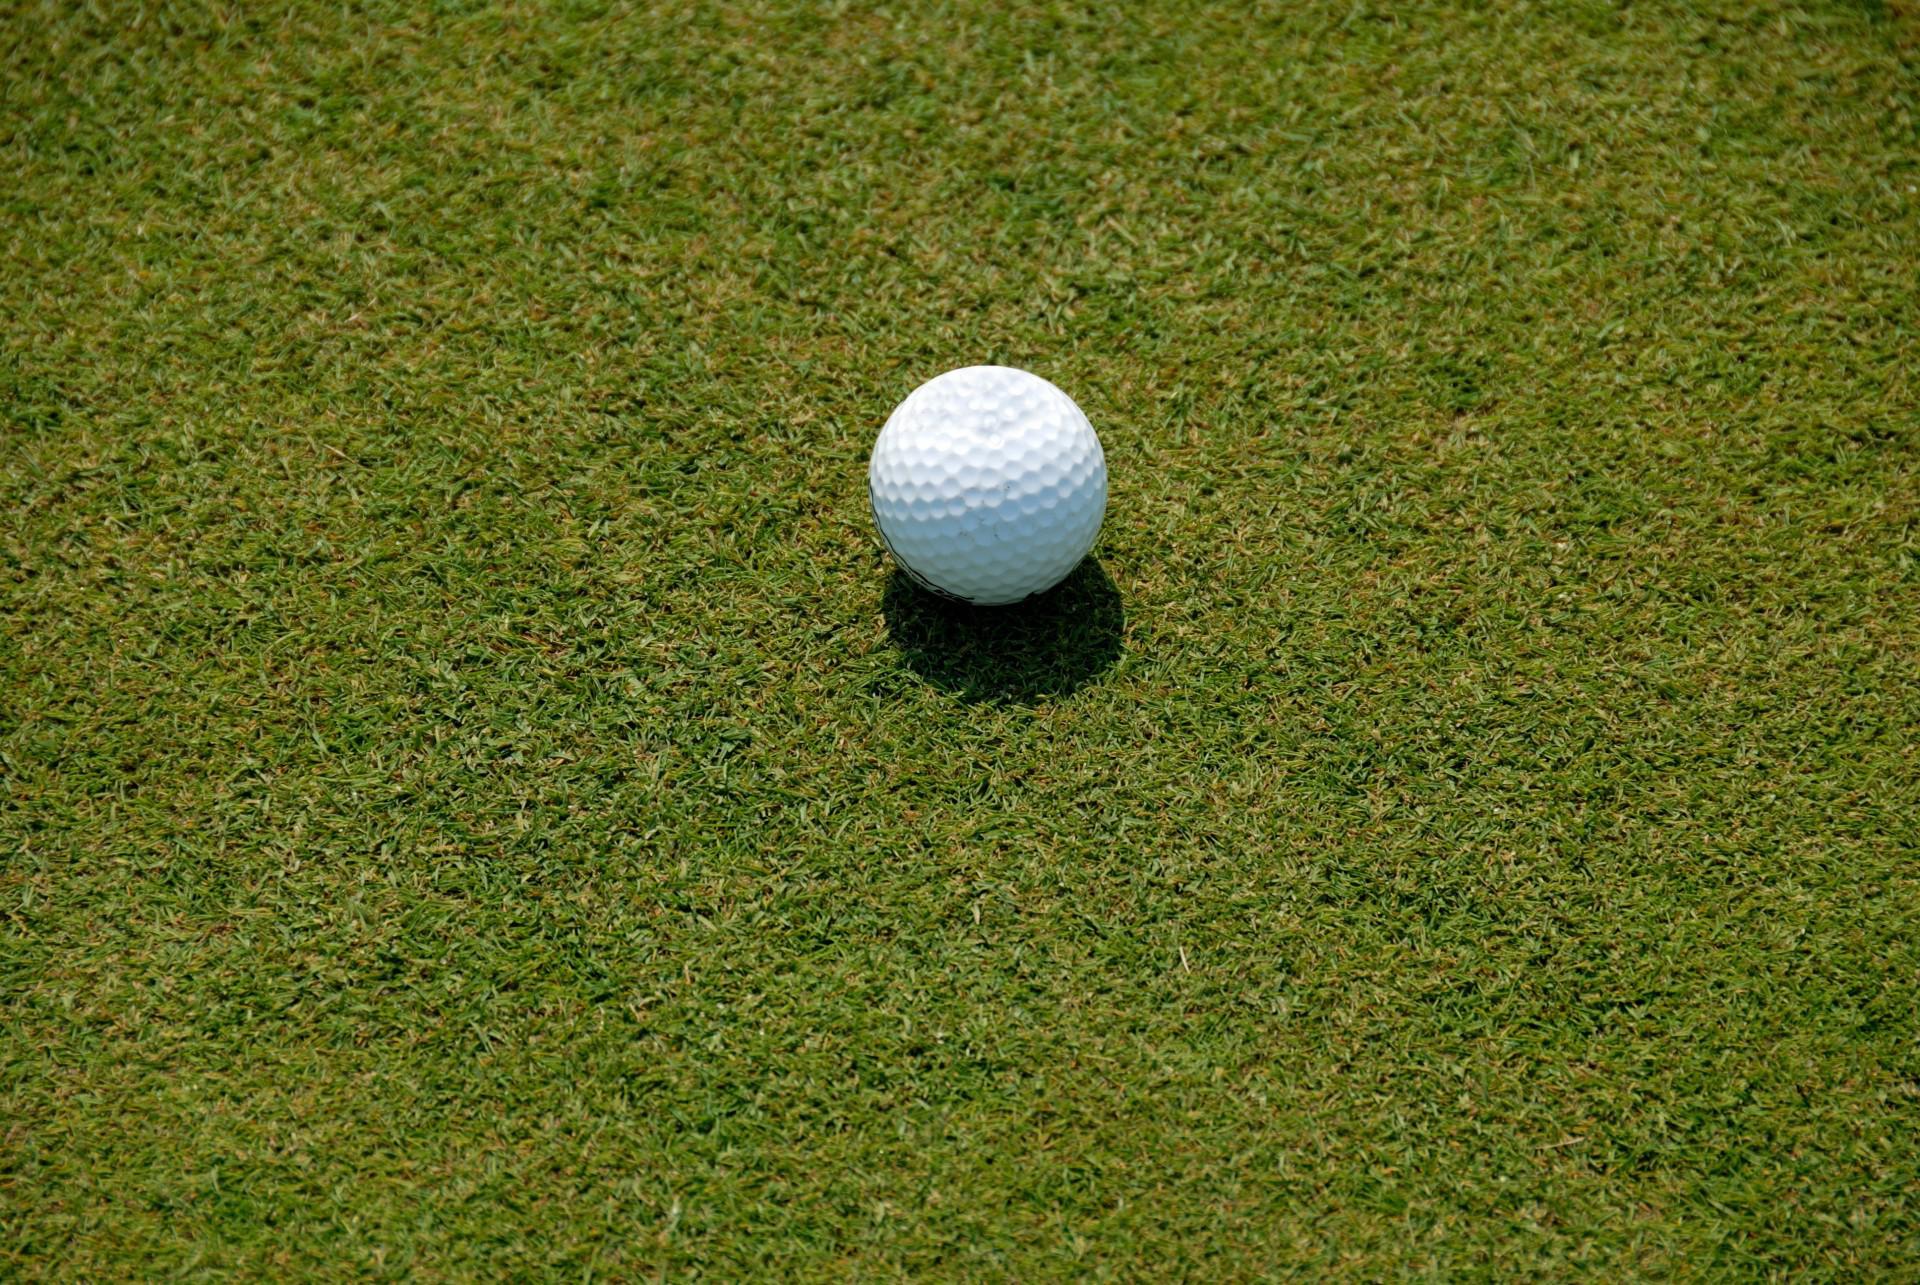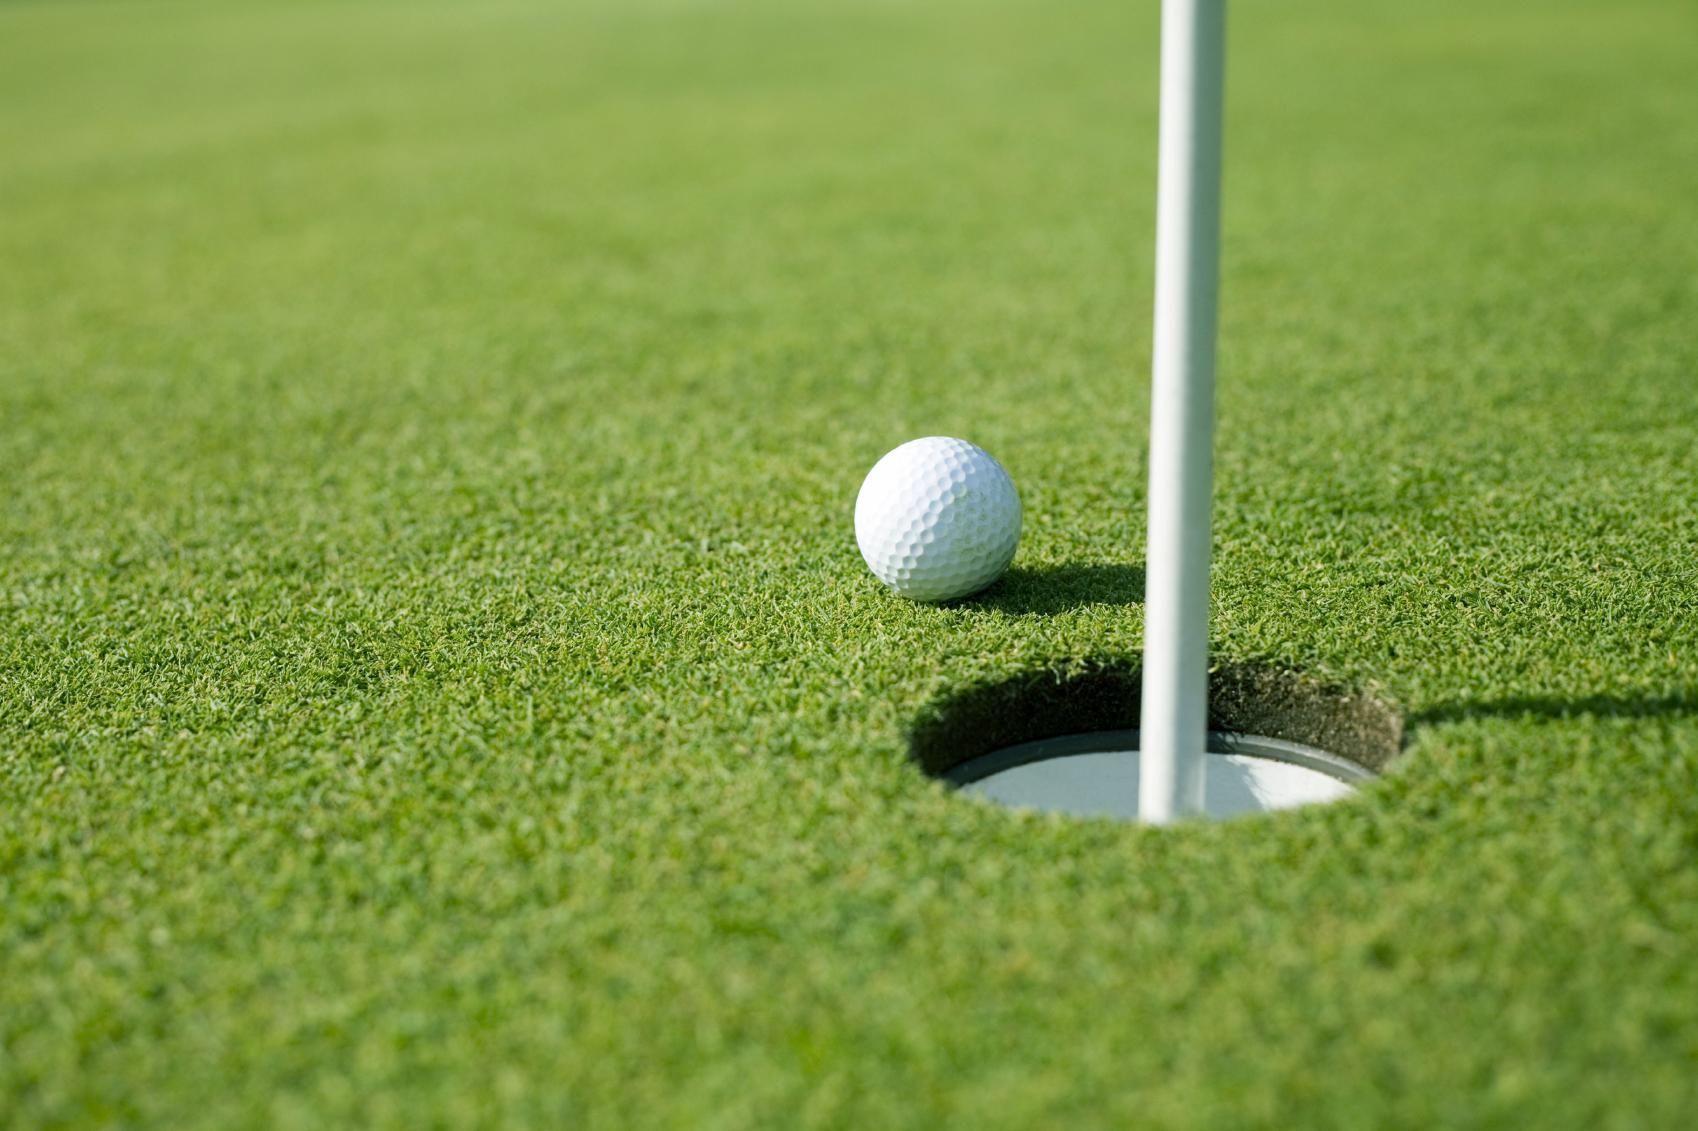The first image is the image on the left, the second image is the image on the right. Examine the images to the left and right. Is the description "Each image shows one golf ball on a green, one of them near a cup with a flag pole." accurate? Answer yes or no. Yes. The first image is the image on the left, the second image is the image on the right. Evaluate the accuracy of this statement regarding the images: "Left image shows one ball next to a hole on a golf green.". Is it true? Answer yes or no. No. 